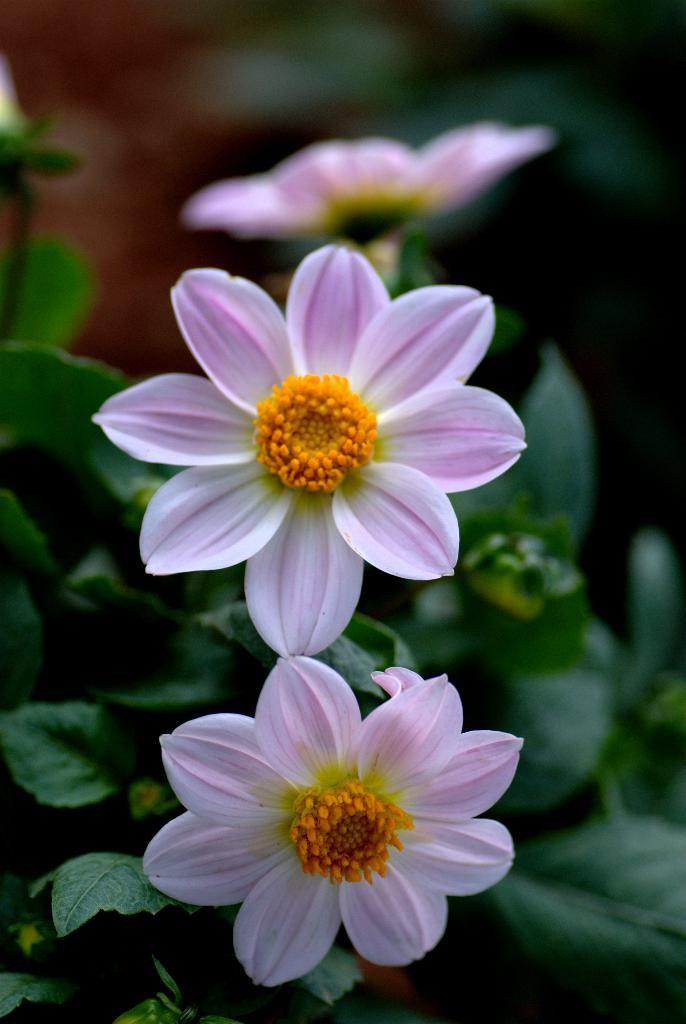What type of flora is present in the image? There are flowers in the image. What colors are the flowers? The flowers are in violet and white colors. What other color is present in the image? There is an orange color object in the image. What can be seen in the background of the image? There are green leaves in the background of the image. What type of engine is used to power the musical instrument in the image? There is no engine or musical instrument present in the image; it features flowers and an orange object. 